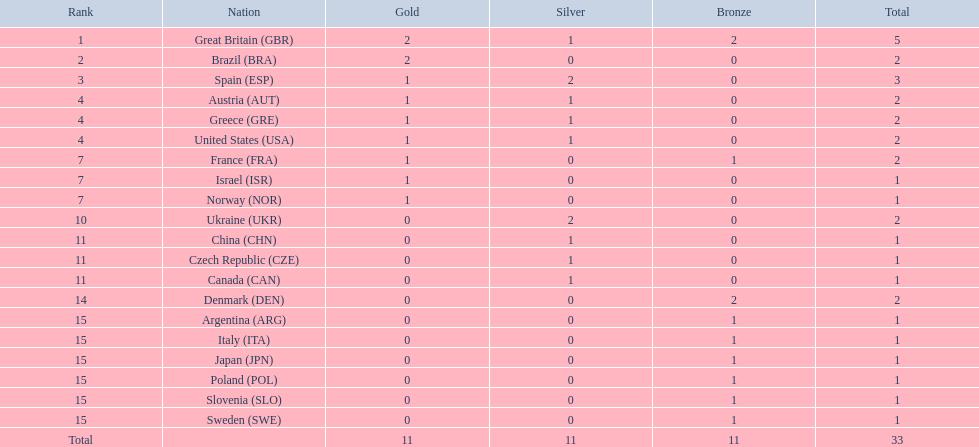How many medals did each country receive? 5, 2, 3, 2, 2, 2, 2, 1, 1, 2, 1, 1, 1, 2, 1, 1, 1, 1, 1, 1. Which country received 3 medals? Spain (ESP). 